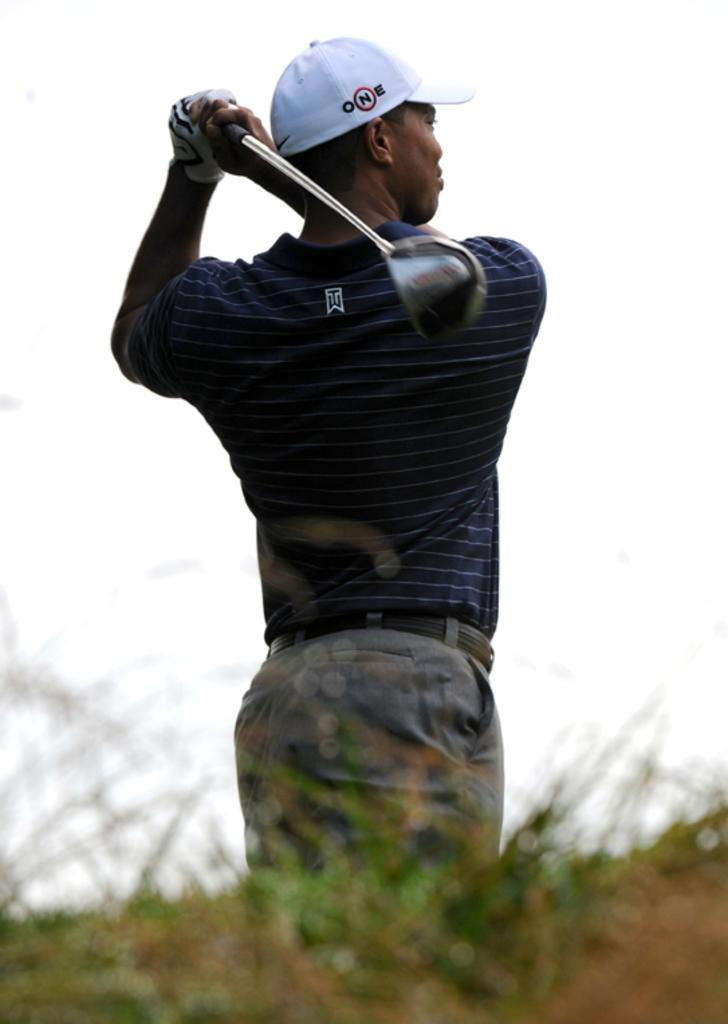What is the man in the image doing? The man is playing golf. What type of clothing is the man wearing? The man is wearing a t-shirt, trousers, and a cap. What is the surface beneath the man's feet in the image? There is grass at the bottom of the image. What is visible at the top of the image? The sky is visible at the top of the image. What type of stone is the man using to cut the vegetables in the image? There is no stone or vegetables present in the image; the man is playing golf. How many beds can be seen in the image? There are no beds present in the image. 